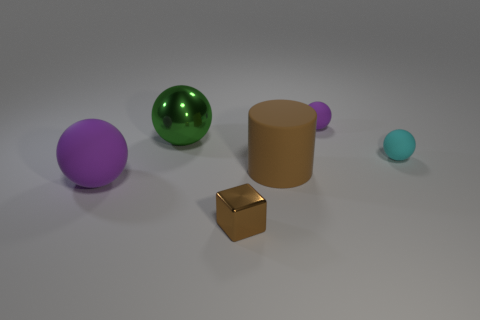What number of small metal blocks have the same color as the big metallic ball?
Make the answer very short. 0. How many cylinders are made of the same material as the small brown thing?
Make the answer very short. 0. Does the tiny metallic block have the same color as the tiny thing behind the big green object?
Offer a very short reply. No. The large thing to the right of the green object on the left side of the cyan rubber ball is what color?
Offer a terse response. Brown. There is a metal thing that is the same size as the brown rubber thing; what is its color?
Your response must be concise. Green. Are there any large brown things that have the same shape as the green object?
Offer a very short reply. No. What is the shape of the tiny cyan thing?
Your answer should be very brief. Sphere. Are there more green metal spheres that are behind the big green object than large rubber spheres in front of the brown cylinder?
Offer a terse response. No. What is the big object that is both left of the brown rubber object and behind the large purple matte object made of?
Your answer should be compact. Metal. There is a small purple object that is the same shape as the big shiny thing; what is it made of?
Offer a terse response. Rubber. 